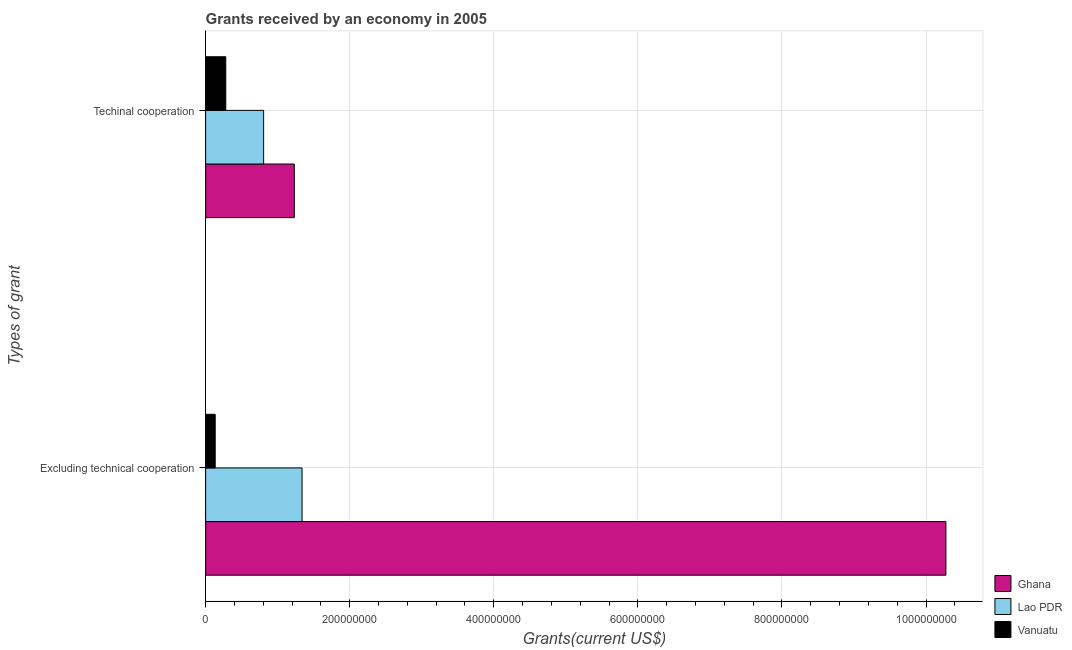How many different coloured bars are there?
Make the answer very short. 3. Are the number of bars per tick equal to the number of legend labels?
Your response must be concise. Yes. Are the number of bars on each tick of the Y-axis equal?
Your answer should be very brief. Yes. What is the label of the 2nd group of bars from the top?
Offer a terse response. Excluding technical cooperation. What is the amount of grants received(including technical cooperation) in Ghana?
Offer a very short reply. 1.23e+08. Across all countries, what is the maximum amount of grants received(excluding technical cooperation)?
Provide a succinct answer. 1.03e+09. Across all countries, what is the minimum amount of grants received(excluding technical cooperation)?
Provide a short and direct response. 1.33e+07. In which country was the amount of grants received(excluding technical cooperation) maximum?
Your answer should be very brief. Ghana. In which country was the amount of grants received(including technical cooperation) minimum?
Provide a short and direct response. Vanuatu. What is the total amount of grants received(including technical cooperation) in the graph?
Your answer should be compact. 2.32e+08. What is the difference between the amount of grants received(including technical cooperation) in Ghana and that in Vanuatu?
Your answer should be compact. 9.51e+07. What is the difference between the amount of grants received(excluding technical cooperation) in Ghana and the amount of grants received(including technical cooperation) in Vanuatu?
Ensure brevity in your answer.  1.00e+09. What is the average amount of grants received(including technical cooperation) per country?
Your answer should be compact. 7.72e+07. What is the difference between the amount of grants received(excluding technical cooperation) and amount of grants received(including technical cooperation) in Vanuatu?
Give a very brief answer. -1.47e+07. What is the ratio of the amount of grants received(including technical cooperation) in Vanuatu to that in Lao PDR?
Provide a succinct answer. 0.35. Is the amount of grants received(including technical cooperation) in Ghana less than that in Vanuatu?
Your answer should be compact. No. In how many countries, is the amount of grants received(excluding technical cooperation) greater than the average amount of grants received(excluding technical cooperation) taken over all countries?
Your answer should be very brief. 1. What does the 3rd bar from the top in Excluding technical cooperation represents?
Offer a terse response. Ghana. What is the difference between two consecutive major ticks on the X-axis?
Keep it short and to the point. 2.00e+08. Does the graph contain grids?
Your answer should be very brief. Yes. How are the legend labels stacked?
Offer a terse response. Vertical. What is the title of the graph?
Keep it short and to the point. Grants received by an economy in 2005. Does "Upper middle income" appear as one of the legend labels in the graph?
Offer a terse response. No. What is the label or title of the X-axis?
Keep it short and to the point. Grants(current US$). What is the label or title of the Y-axis?
Your answer should be very brief. Types of grant. What is the Grants(current US$) of Ghana in Excluding technical cooperation?
Provide a short and direct response. 1.03e+09. What is the Grants(current US$) of Lao PDR in Excluding technical cooperation?
Make the answer very short. 1.34e+08. What is the Grants(current US$) in Vanuatu in Excluding technical cooperation?
Your answer should be compact. 1.33e+07. What is the Grants(current US$) in Ghana in Techinal cooperation?
Make the answer very short. 1.23e+08. What is the Grants(current US$) of Lao PDR in Techinal cooperation?
Keep it short and to the point. 8.05e+07. What is the Grants(current US$) in Vanuatu in Techinal cooperation?
Provide a succinct answer. 2.80e+07. Across all Types of grant, what is the maximum Grants(current US$) in Ghana?
Give a very brief answer. 1.03e+09. Across all Types of grant, what is the maximum Grants(current US$) in Lao PDR?
Offer a terse response. 1.34e+08. Across all Types of grant, what is the maximum Grants(current US$) in Vanuatu?
Ensure brevity in your answer.  2.80e+07. Across all Types of grant, what is the minimum Grants(current US$) of Ghana?
Make the answer very short. 1.23e+08. Across all Types of grant, what is the minimum Grants(current US$) in Lao PDR?
Your answer should be very brief. 8.05e+07. Across all Types of grant, what is the minimum Grants(current US$) of Vanuatu?
Offer a terse response. 1.33e+07. What is the total Grants(current US$) in Ghana in the graph?
Your answer should be very brief. 1.15e+09. What is the total Grants(current US$) of Lao PDR in the graph?
Offer a terse response. 2.14e+08. What is the total Grants(current US$) in Vanuatu in the graph?
Your response must be concise. 4.12e+07. What is the difference between the Grants(current US$) of Ghana in Excluding technical cooperation and that in Techinal cooperation?
Offer a very short reply. 9.04e+08. What is the difference between the Grants(current US$) of Lao PDR in Excluding technical cooperation and that in Techinal cooperation?
Keep it short and to the point. 5.33e+07. What is the difference between the Grants(current US$) of Vanuatu in Excluding technical cooperation and that in Techinal cooperation?
Ensure brevity in your answer.  -1.47e+07. What is the difference between the Grants(current US$) of Ghana in Excluding technical cooperation and the Grants(current US$) of Lao PDR in Techinal cooperation?
Keep it short and to the point. 9.47e+08. What is the difference between the Grants(current US$) of Ghana in Excluding technical cooperation and the Grants(current US$) of Vanuatu in Techinal cooperation?
Provide a short and direct response. 1.00e+09. What is the difference between the Grants(current US$) of Lao PDR in Excluding technical cooperation and the Grants(current US$) of Vanuatu in Techinal cooperation?
Give a very brief answer. 1.06e+08. What is the average Grants(current US$) of Ghana per Types of grant?
Keep it short and to the point. 5.75e+08. What is the average Grants(current US$) in Lao PDR per Types of grant?
Ensure brevity in your answer.  1.07e+08. What is the average Grants(current US$) in Vanuatu per Types of grant?
Make the answer very short. 2.06e+07. What is the difference between the Grants(current US$) in Ghana and Grants(current US$) in Lao PDR in Excluding technical cooperation?
Make the answer very short. 8.94e+08. What is the difference between the Grants(current US$) in Ghana and Grants(current US$) in Vanuatu in Excluding technical cooperation?
Offer a very short reply. 1.01e+09. What is the difference between the Grants(current US$) in Lao PDR and Grants(current US$) in Vanuatu in Excluding technical cooperation?
Your response must be concise. 1.21e+08. What is the difference between the Grants(current US$) of Ghana and Grants(current US$) of Lao PDR in Techinal cooperation?
Offer a very short reply. 4.26e+07. What is the difference between the Grants(current US$) in Ghana and Grants(current US$) in Vanuatu in Techinal cooperation?
Give a very brief answer. 9.51e+07. What is the difference between the Grants(current US$) in Lao PDR and Grants(current US$) in Vanuatu in Techinal cooperation?
Give a very brief answer. 5.26e+07. What is the ratio of the Grants(current US$) in Ghana in Excluding technical cooperation to that in Techinal cooperation?
Offer a very short reply. 8.35. What is the ratio of the Grants(current US$) in Lao PDR in Excluding technical cooperation to that in Techinal cooperation?
Ensure brevity in your answer.  1.66. What is the ratio of the Grants(current US$) of Vanuatu in Excluding technical cooperation to that in Techinal cooperation?
Your answer should be compact. 0.48. What is the difference between the highest and the second highest Grants(current US$) in Ghana?
Make the answer very short. 9.04e+08. What is the difference between the highest and the second highest Grants(current US$) in Lao PDR?
Offer a terse response. 5.33e+07. What is the difference between the highest and the second highest Grants(current US$) of Vanuatu?
Provide a succinct answer. 1.47e+07. What is the difference between the highest and the lowest Grants(current US$) of Ghana?
Your response must be concise. 9.04e+08. What is the difference between the highest and the lowest Grants(current US$) of Lao PDR?
Give a very brief answer. 5.33e+07. What is the difference between the highest and the lowest Grants(current US$) in Vanuatu?
Provide a short and direct response. 1.47e+07. 